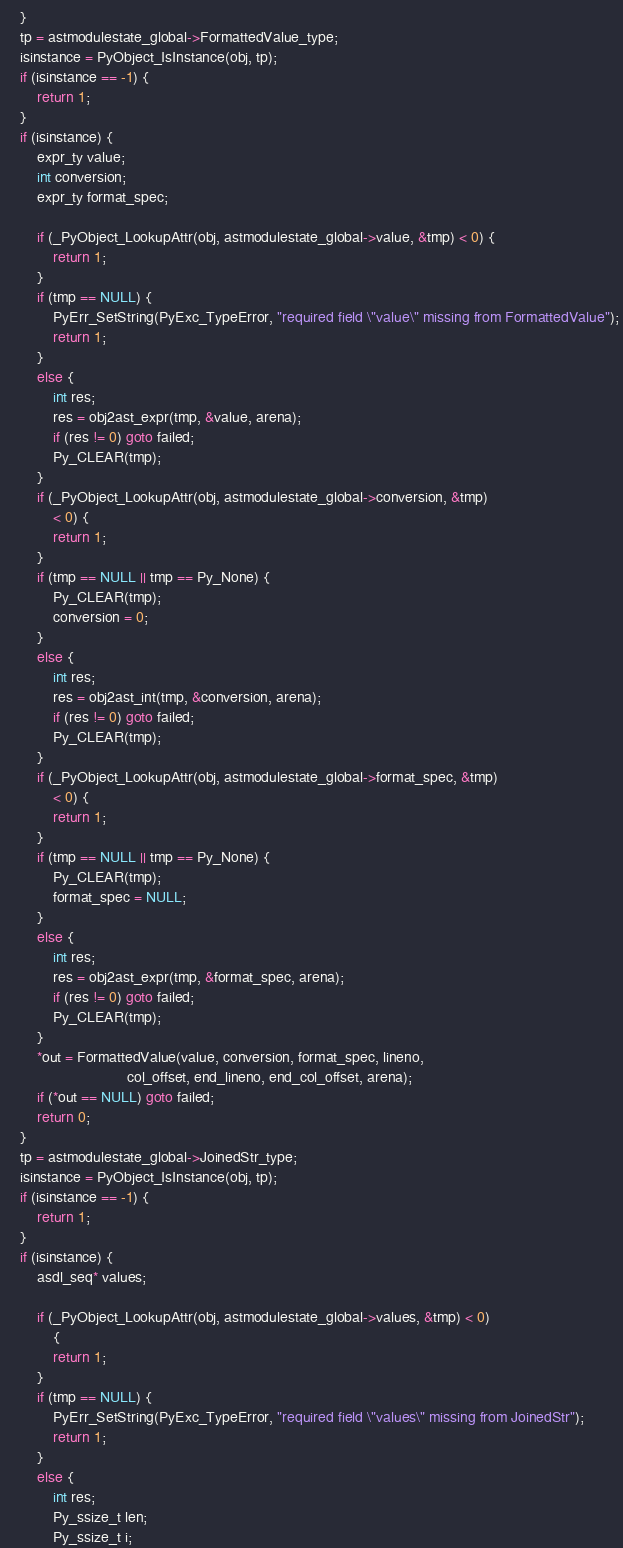Convert code to text. <code><loc_0><loc_0><loc_500><loc_500><_C_>    }
    tp = astmodulestate_global->FormattedValue_type;
    isinstance = PyObject_IsInstance(obj, tp);
    if (isinstance == -1) {
        return 1;
    }
    if (isinstance) {
        expr_ty value;
        int conversion;
        expr_ty format_spec;

        if (_PyObject_LookupAttr(obj, astmodulestate_global->value, &tmp) < 0) {
            return 1;
        }
        if (tmp == NULL) {
            PyErr_SetString(PyExc_TypeError, "required field \"value\" missing from FormattedValue");
            return 1;
        }
        else {
            int res;
            res = obj2ast_expr(tmp, &value, arena);
            if (res != 0) goto failed;
            Py_CLEAR(tmp);
        }
        if (_PyObject_LookupAttr(obj, astmodulestate_global->conversion, &tmp)
            < 0) {
            return 1;
        }
        if (tmp == NULL || tmp == Py_None) {
            Py_CLEAR(tmp);
            conversion = 0;
        }
        else {
            int res;
            res = obj2ast_int(tmp, &conversion, arena);
            if (res != 0) goto failed;
            Py_CLEAR(tmp);
        }
        if (_PyObject_LookupAttr(obj, astmodulestate_global->format_spec, &tmp)
            < 0) {
            return 1;
        }
        if (tmp == NULL || tmp == Py_None) {
            Py_CLEAR(tmp);
            format_spec = NULL;
        }
        else {
            int res;
            res = obj2ast_expr(tmp, &format_spec, arena);
            if (res != 0) goto failed;
            Py_CLEAR(tmp);
        }
        *out = FormattedValue(value, conversion, format_spec, lineno,
                              col_offset, end_lineno, end_col_offset, arena);
        if (*out == NULL) goto failed;
        return 0;
    }
    tp = astmodulestate_global->JoinedStr_type;
    isinstance = PyObject_IsInstance(obj, tp);
    if (isinstance == -1) {
        return 1;
    }
    if (isinstance) {
        asdl_seq* values;

        if (_PyObject_LookupAttr(obj, astmodulestate_global->values, &tmp) < 0)
            {
            return 1;
        }
        if (tmp == NULL) {
            PyErr_SetString(PyExc_TypeError, "required field \"values\" missing from JoinedStr");
            return 1;
        }
        else {
            int res;
            Py_ssize_t len;
            Py_ssize_t i;</code> 